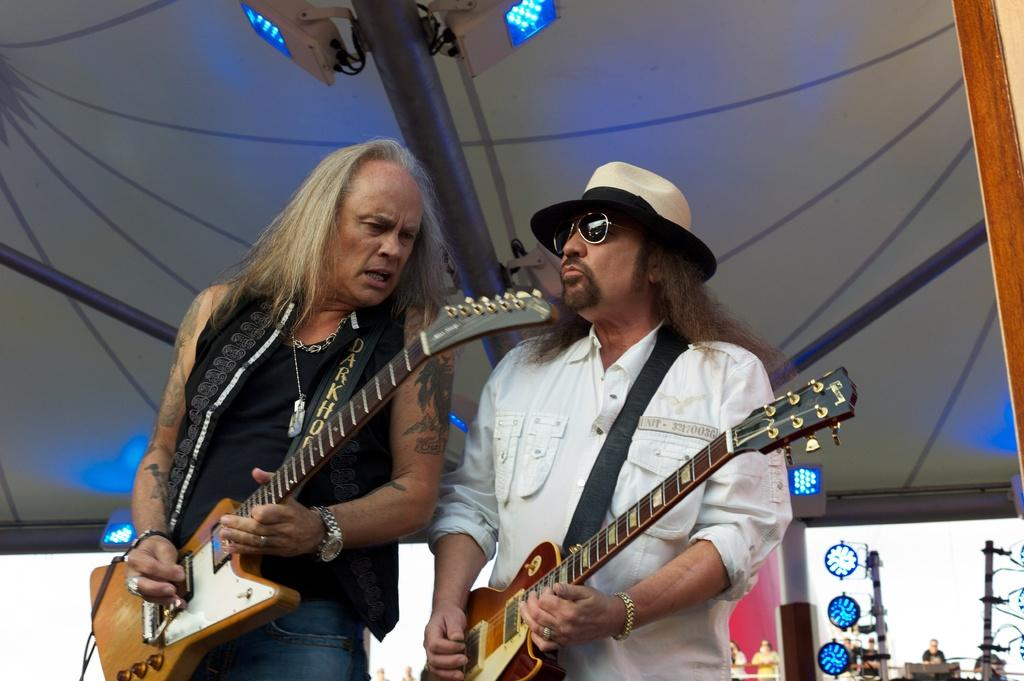What object is present in the image that can provide shelter from the rain? There is an umbrella in the image. How many people are in the image? There are two people in the image. What are the people holding in the image? Both people are holding guitars. Can you describe the clothing of one of the people in the image? The person wearing the white shirt is also wearing goggles. Where is the person wearing the white shirt standing in the image? The person wearing the white shirt is standing on the right side of the image. How many pizzas are being delivered to the people in the image? There are no pizzas present in the image. What route are the people in the image taking to their next gig? The image does not provide information about the people's route or destination. 